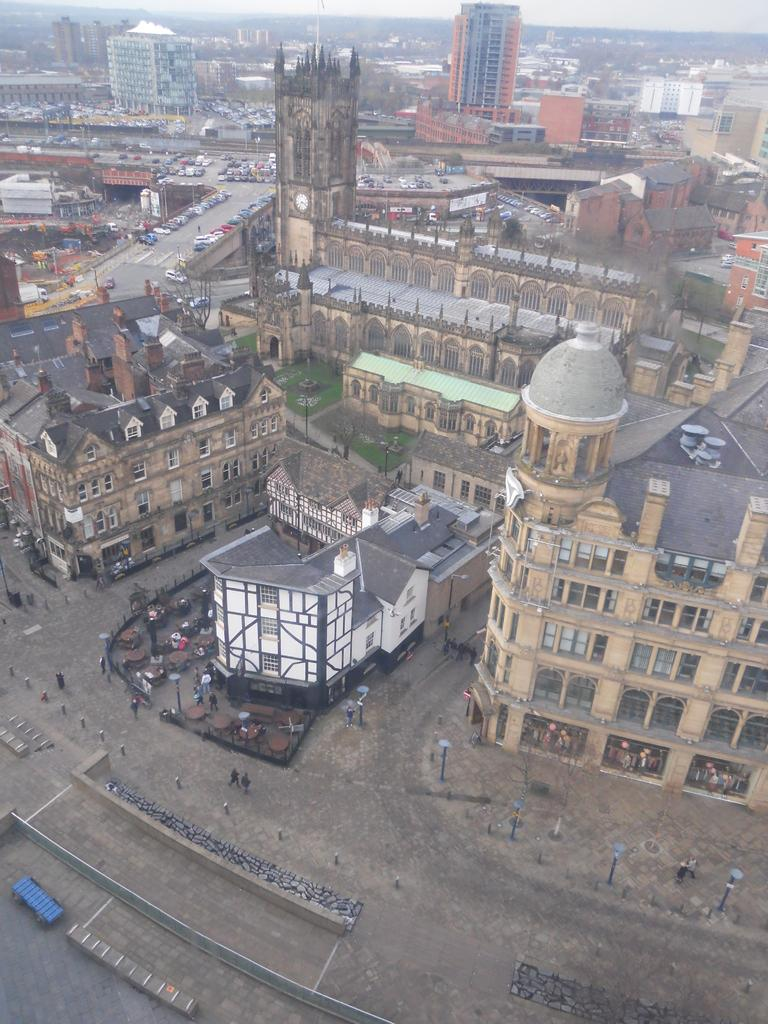What type of scene is depicted in the image? The image shows a view of the city. What structures can be seen in the image? There are buildings in the image. What are the roads used for in the image? Vehicles are visible on the roads. Are there any people present in the image? Yes, there are people standing in the image. What type of lighting is present in the image? There are street lights in the image. How do the people in the image rub the buildings? There is no indication in the image that the people are rubbing the buildings; they are simply standing in the scene. 